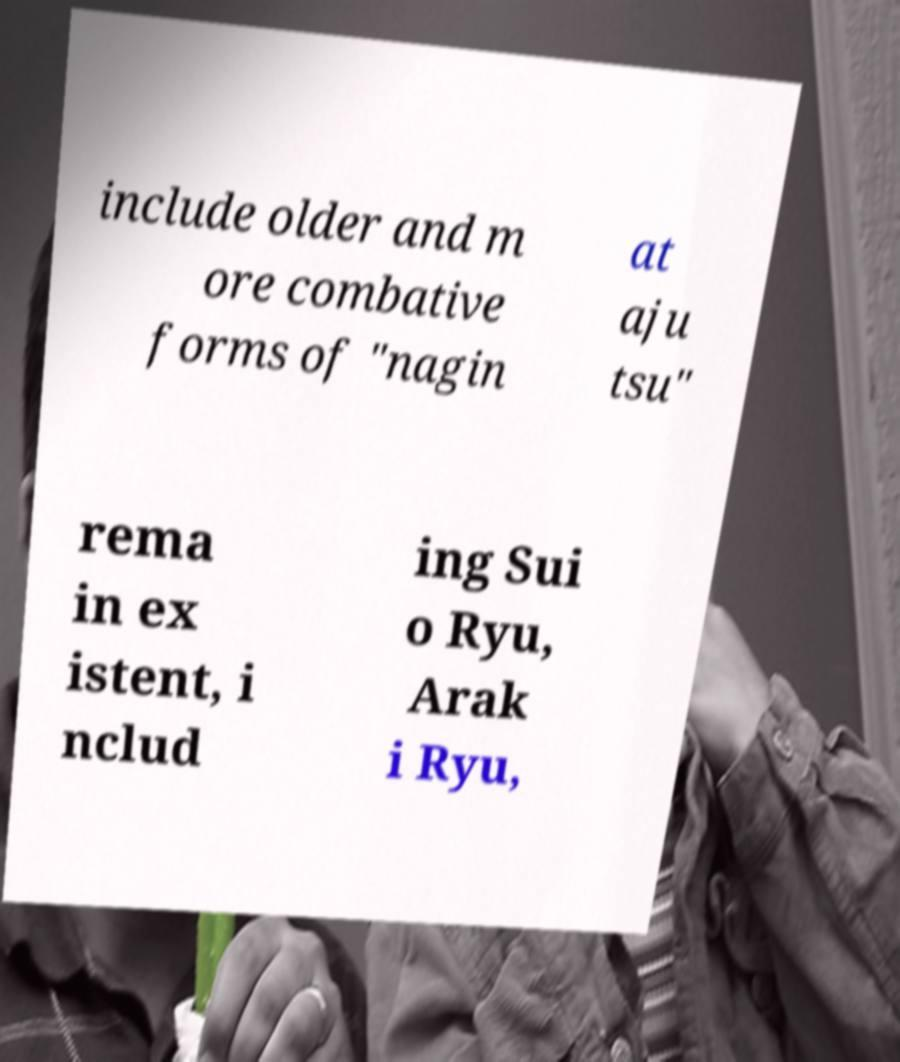Can you read and provide the text displayed in the image?This photo seems to have some interesting text. Can you extract and type it out for me? include older and m ore combative forms of "nagin at aju tsu" rema in ex istent, i nclud ing Sui o Ryu, Arak i Ryu, 